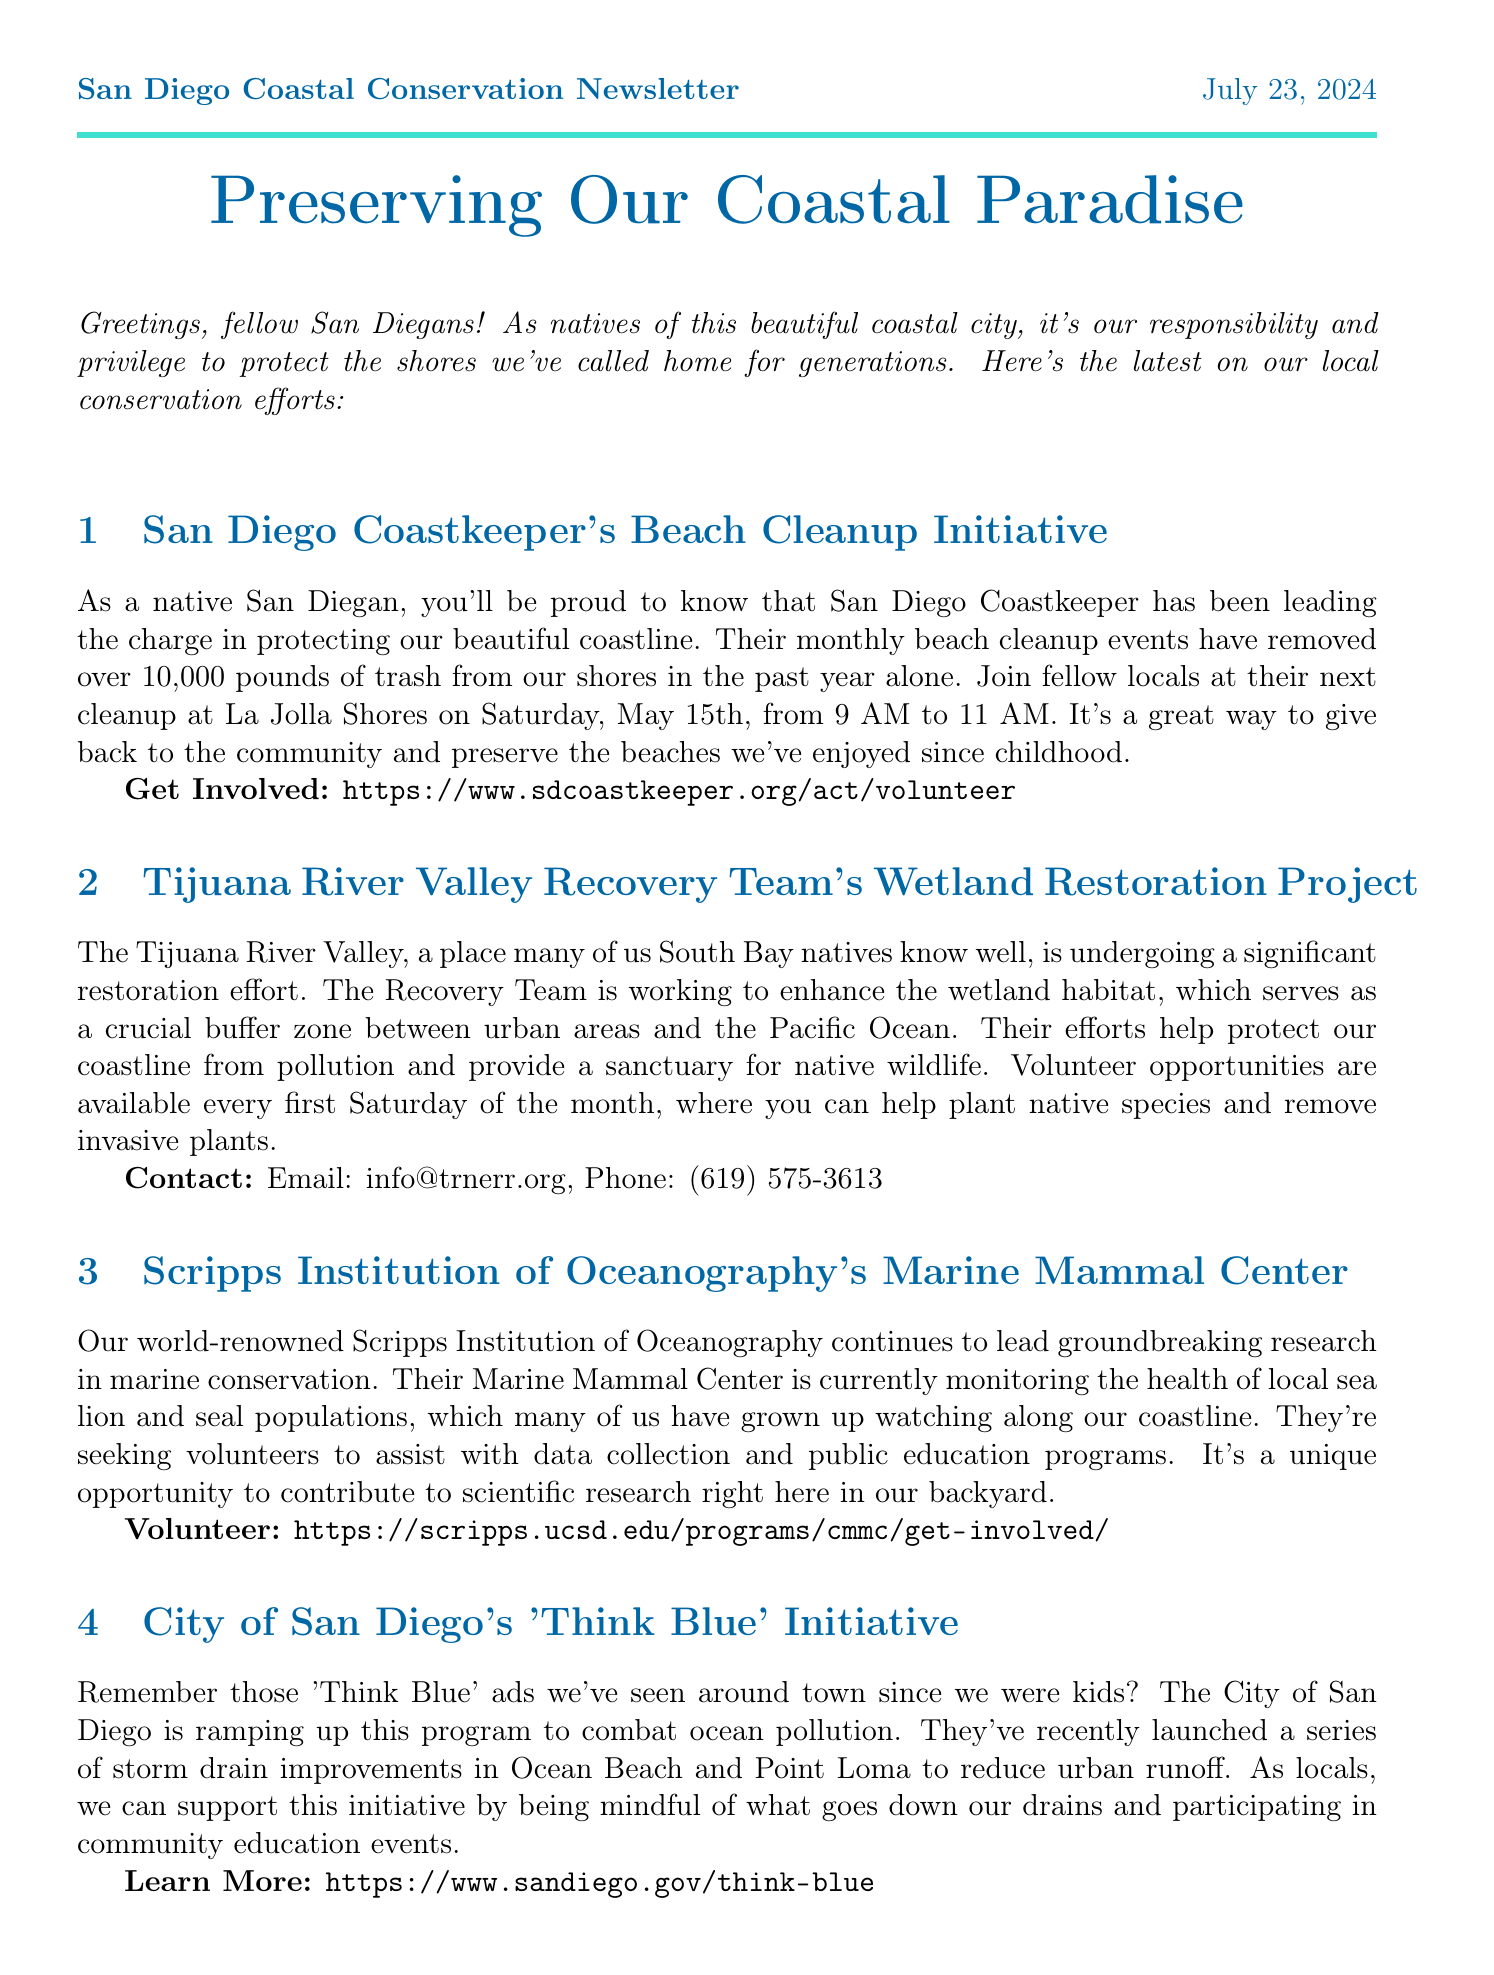What is the date of the next beach cleanup? The next beach cleanup is scheduled for Saturday, May 15th.
Answer: May 15th How many pounds of trash have been removed by San Diego Coastkeeper? San Diego Coastkeeper has removed over 10,000 pounds of trash from the beaches in the past year.
Answer: 10,000 pounds What organization is involved with the Marine Mammal Center? The organization involved is Scripps Institution of Oceanography.
Answer: Scripps Institution of Oceanography What is the volunteer opportunity schedule for the Tijuana River Valley Recovery Team? Volunteers can help every first Saturday of the month.
Answer: First Saturday of the month What initiative aims to combat ocean pollution? The initiative is called 'Think Blue.'
Answer: Think Blue How can volunteers assist at the San Diego Bay National Wildlife Refuge? Volunteers can help with habitat restoration and bird surveys.
Answer: Habitat restoration and bird surveys What type of wildlife is the San Diego Bay National Wildlife Refuge protecting? The refuge provides protection for local shorebirds and salt marsh habitat.
Answer: Shorebirds and salt marsh habitat What is the main goal of the City of San Diego's 'Think Blue' initiative? The main goal is to combat ocean pollution.
Answer: Combat ocean pollution 